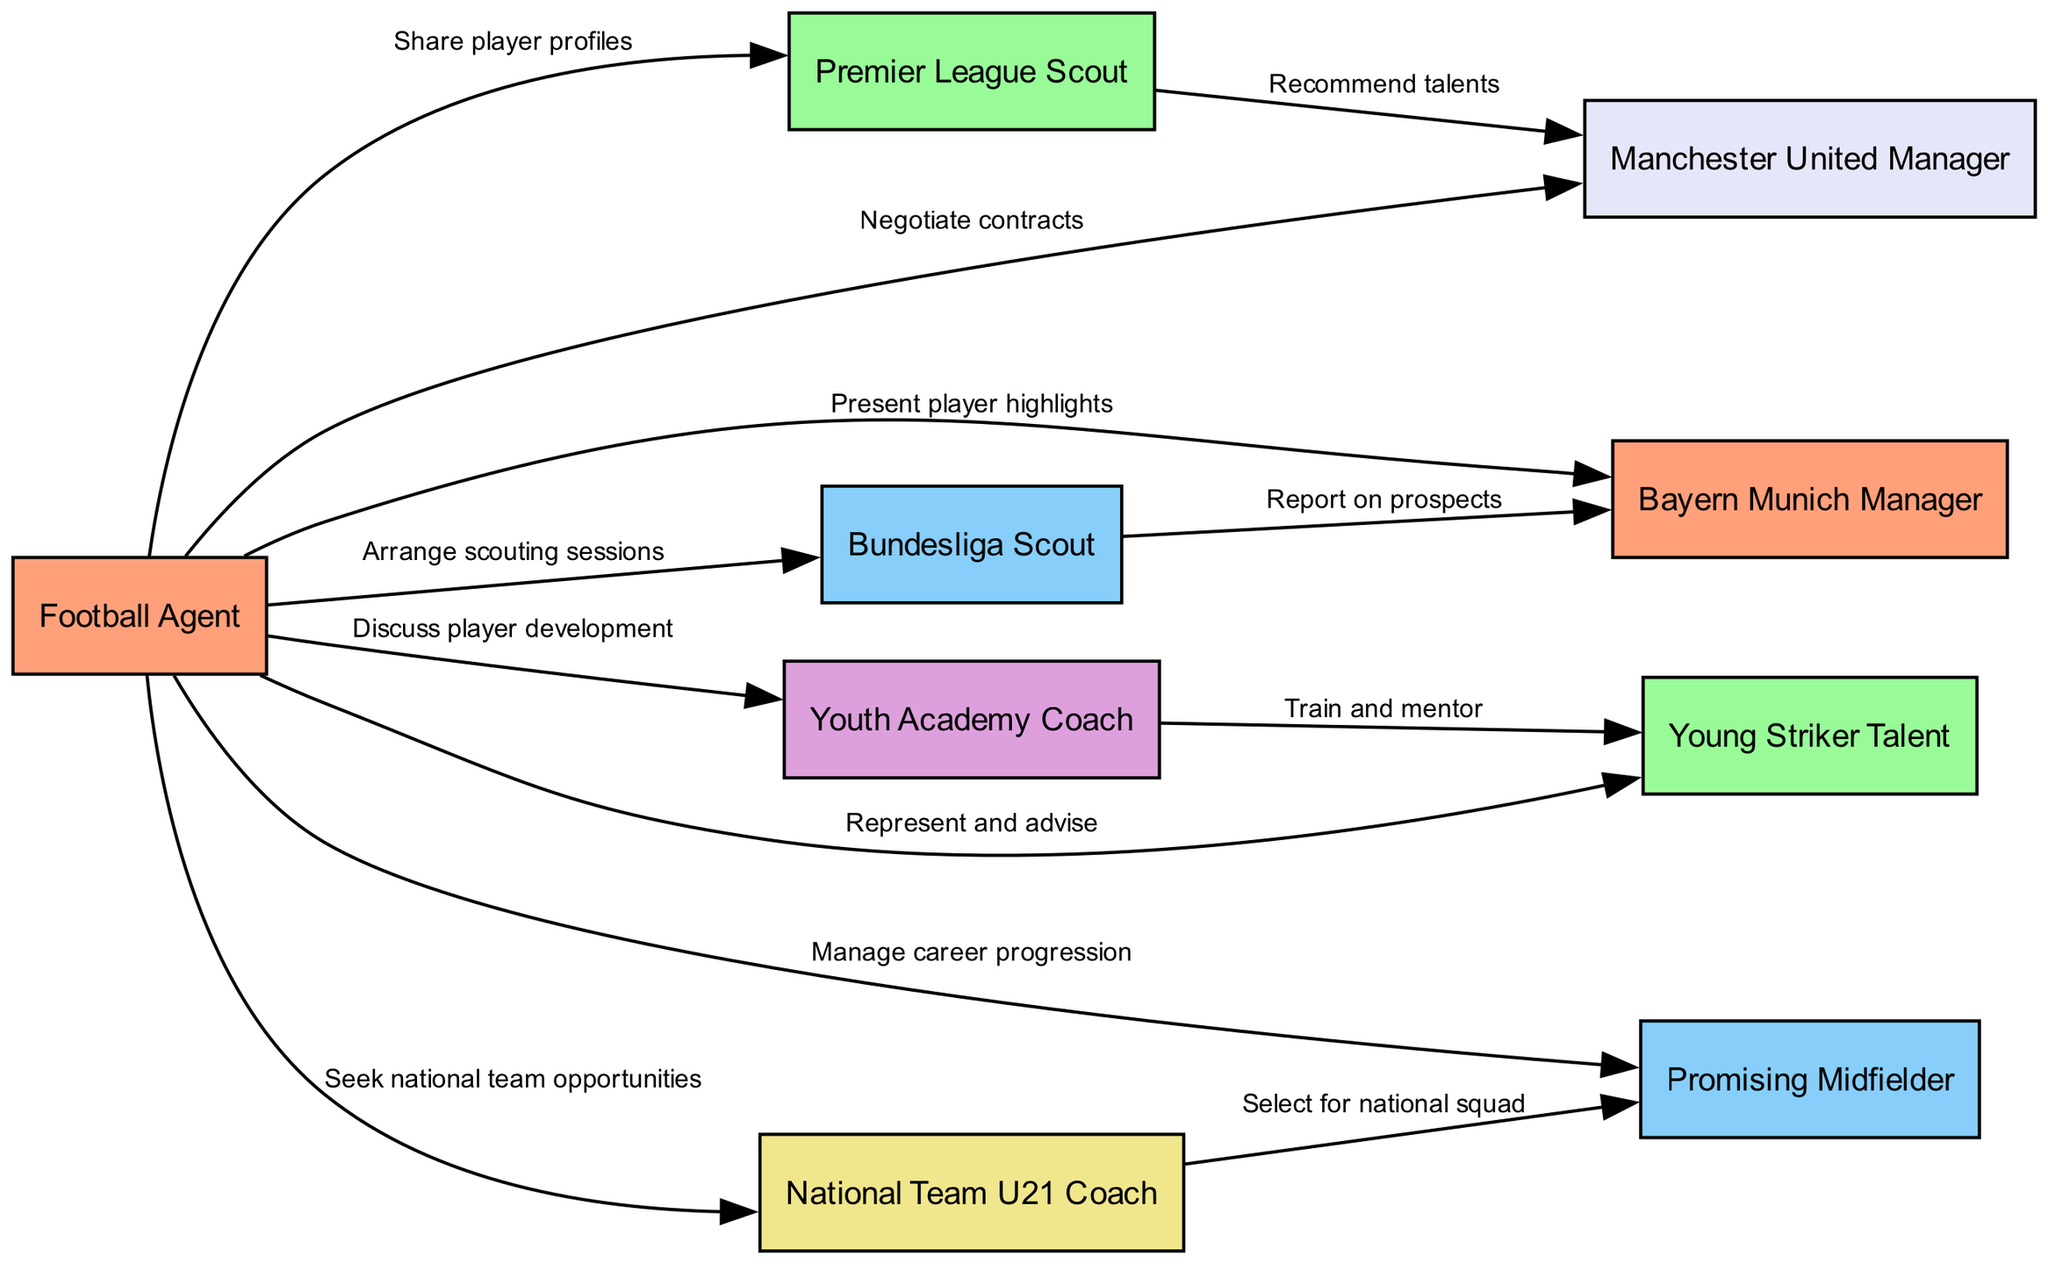What is the total number of nodes in the diagram? The diagram contains a list of nodes in the data. By counting the entries in the "nodes" section, we see that there are 9 nodes total.
Answer: 9 How many edges connect the Football Agent to other nodes? The Football Agent is shown to connect to multiple nodes, specifically by examining the "edges" section. There are 8 edges where the "from" attribute is "Agent."
Answer: 8 Which scout is associated with Manchester United Manager? To find the relevant connection, we trace the edges starting from the Premier League Scout, looking for the Manager with Manchester United. The edge from Scout1 to Manager1 indicates the connection.
Answer: Premier League Scout Which player is trained by the Youth Academy Coach? By reviewing the edges, we find that the Youth Academy Coach connects to Player1. This means Player1 is the one being mentored and trained by Coach1.
Answer: Young Striker Talent What type of relationship does the Agent have with Player2? By checking the edges where the "from" attribute is "Agent," we see that Agent is related to Player2 through career management. This is described as "Manage career progression."
Answer: Manage career progression Which Manager is connected to the Bundesliga Scout? The edge from Scout2 indicates that they have a connection to the Bayern Munich Manager through the edge labeled "Report on prospects." Thus, the answer is the Bayern Munich Manager.
Answer: Bayern Munich Manager How many scouts are represented in the diagram? A quick count of the nodes where the label contains "Scout" shows two distinct scouts: Scout1 and Scout2. Thus, there are two scouts represented in the diagram.
Answer: 2 What is the role of Coach2 in the diagram? To identify Coach2's role, we can look at the node labeled "Coach2," which is defined as the "National Team U21 Coach." Therefore, the answer is the role as defined.
Answer: National Team U21 Coach Who does the Premier League Scout recommend talents to? Following the edge from Scout1, we find that the recommendation goes directly to Manager1, indicating the relationship where Scout1 is recommending talents specifically to the Manchester United Manager.
Answer: Manchester United Manager 